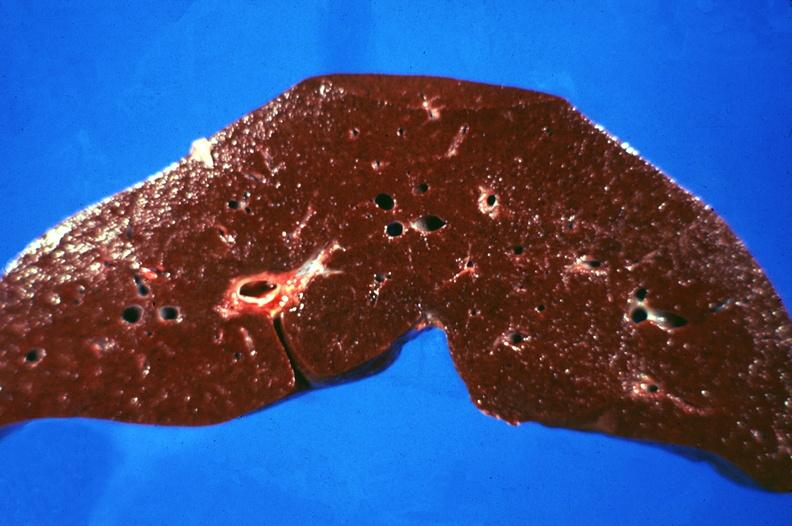what does this image show?
Answer the question using a single word or phrase. Liver 